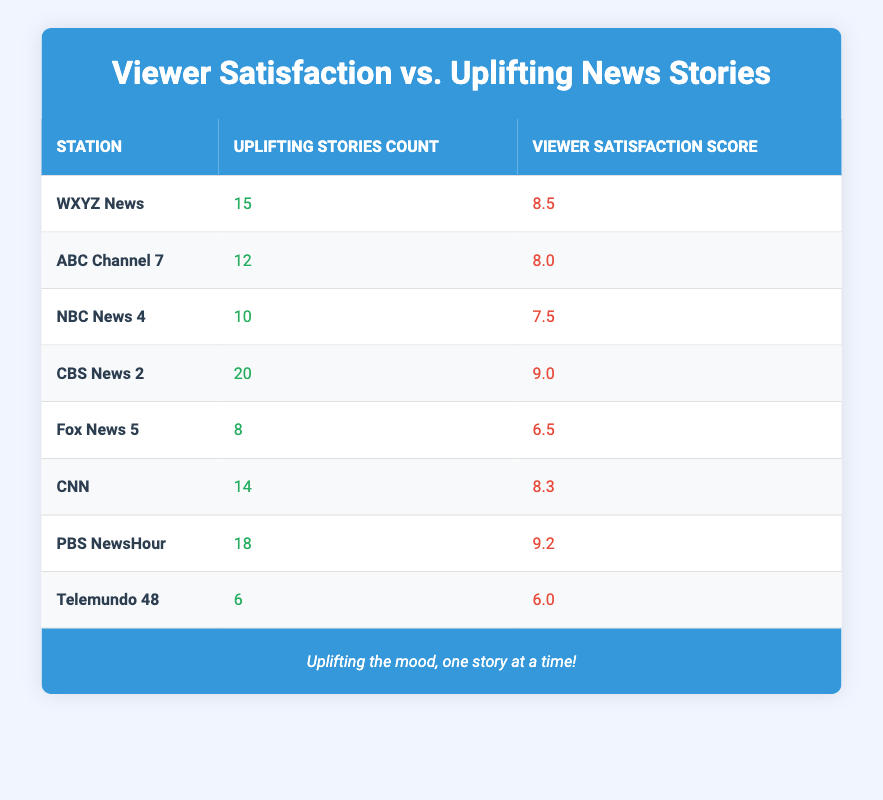What is the viewer satisfaction score for PBS NewsHour? The viewer satisfaction score can be found in the table under PBS NewsHour. It shows a score of 9.2.
Answer: 9.2 How many uplifting stories did Fox News 5 air? The count of uplifting stories for Fox News 5 is listed in the table as 8.
Answer: 8 Which station has the highest viewer satisfaction score? By looking through the viewer satisfaction scores, PBS NewsHour has the highest score of 9.2.
Answer: PBS NewsHour What is the average viewer satisfaction score among all stations? The viewer satisfaction scores are: 8.5, 8.0, 7.5, 9.0, 6.5, 8.3, 9.2, and 6.0. Adding these gives a total of 57.0. There are 8 stations, so the average score is 57.0 / 8 = 7.125.
Answer: 7.125 Is there any station with a viewer satisfaction score below 7? By examining the scores, Fox News 5 at 6.5 and Telemundo 48 at 6.0 both have scores below 7. Therefore, the answer is yes.
Answer: Yes How many more uplifting stories does CBS News 2 have compared to NBC News 4? CBS News 2 has 20 uplifting stories while NBC News 4 has 10. The difference is 20 - 10 = 10.
Answer: 10 Which station has the lowest viewer satisfaction score? The table indicates that Telemundo 48 has the lowest viewer satisfaction score at 6.0.
Answer: Telemundo 48 How does the viewer satisfaction score relate to the number of uplifting stories? By analyzing the data, we can determine that there is a positive trend where stations with more uplifting stories tend to have higher viewer satisfaction scores, such as CBS News 2 and PBS NewsHour. However, Fox News 5 and Telemundo 48 have fewer uplifting stories and lower satisfaction scores.
Answer: Positive correlation 